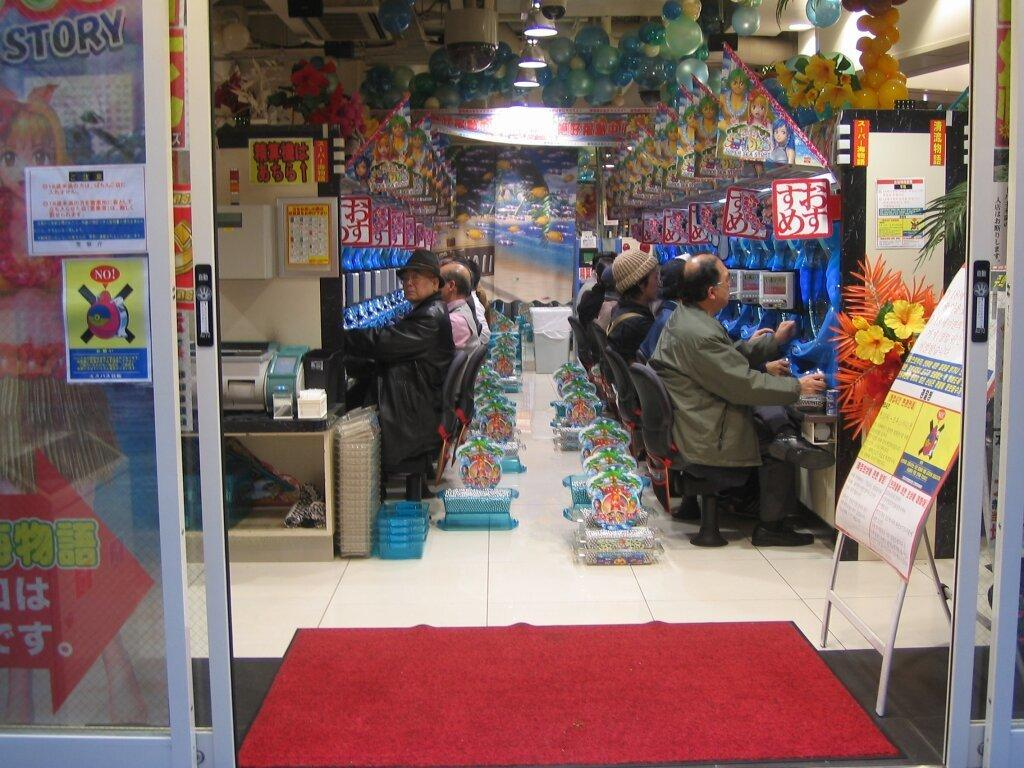Provide a one-sentence caption for the provided image. A sign to the left of the door warns to not do something. 